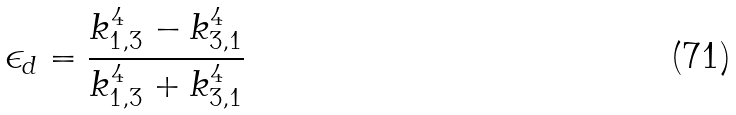<formula> <loc_0><loc_0><loc_500><loc_500>\epsilon _ { d } = \frac { k _ { 1 , 3 } ^ { 4 } - k _ { 3 , 1 } ^ { 4 } } { k _ { 1 , 3 } ^ { 4 } + k _ { 3 , 1 } ^ { 4 } }</formula> 